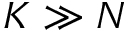Convert formula to latex. <formula><loc_0><loc_0><loc_500><loc_500>K \gg N</formula> 